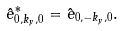<formula> <loc_0><loc_0><loc_500><loc_500>\hat { e } _ { 0 , k _ { y } , 0 } ^ { * } = \hat { e } _ { 0 , - k _ { y } , 0 } .</formula> 